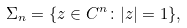<formula> <loc_0><loc_0><loc_500><loc_500>\Sigma _ { n } = \{ z \in { C } ^ { n } \colon | z | = 1 \} ,</formula> 